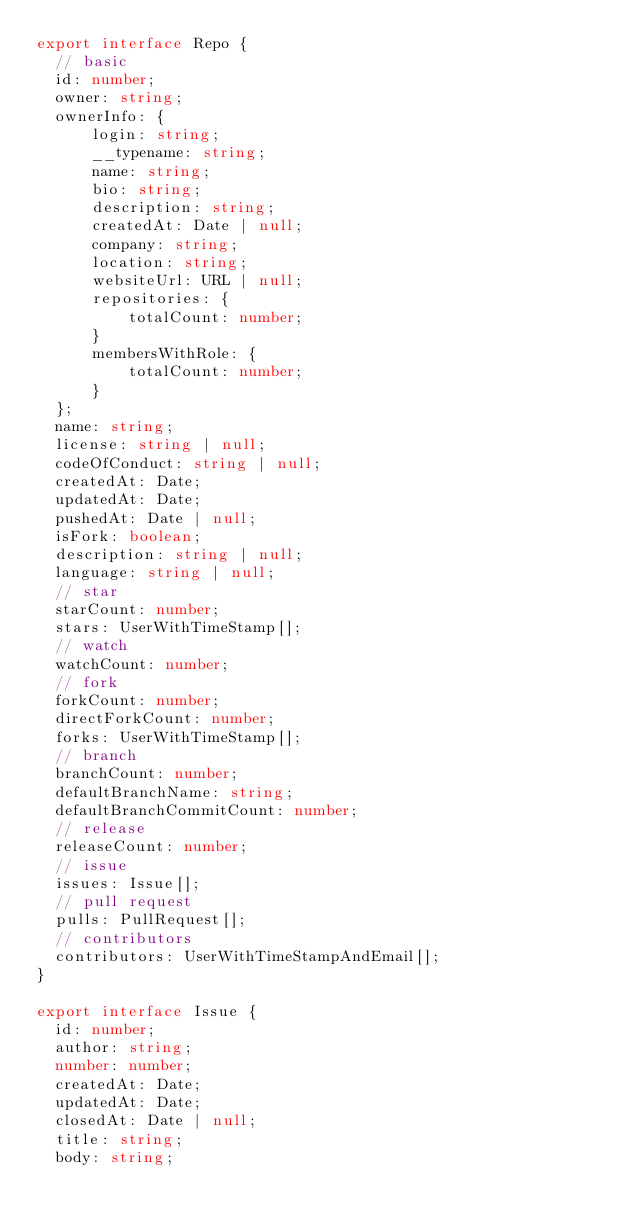Convert code to text. <code><loc_0><loc_0><loc_500><loc_500><_TypeScript_>export interface Repo {
  // basic
  id: number;
  owner: string;
  ownerInfo: {
      login: string;
      __typename: string;
      name: string;
      bio: string;
      description: string;
      createdAt: Date | null;
      company: string;
      location: string;
      websiteUrl: URL | null;
      repositories: {
          totalCount: number;
      }
      membersWithRole: {
          totalCount: number;
      }
  };
  name: string;
  license: string | null;
  codeOfConduct: string | null;
  createdAt: Date;
  updatedAt: Date;
  pushedAt: Date | null;
  isFork: boolean;
  description: string | null;
  language: string | null;
  // star
  starCount: number;
  stars: UserWithTimeStamp[];
  // watch
  watchCount: number;
  // fork
  forkCount: number;
  directForkCount: number;
  forks: UserWithTimeStamp[];
  // branch
  branchCount: number;
  defaultBranchName: string;
  defaultBranchCommitCount: number;
  // release
  releaseCount: number;
  // issue
  issues: Issue[];
  // pull request
  pulls: PullRequest[];
  // contributors
  contributors: UserWithTimeStampAndEmail[];
}

export interface Issue {
  id: number;
  author: string;
  number: number;
  createdAt: Date;
  updatedAt: Date;
  closedAt: Date | null;
  title: string;
  body: string;</code> 